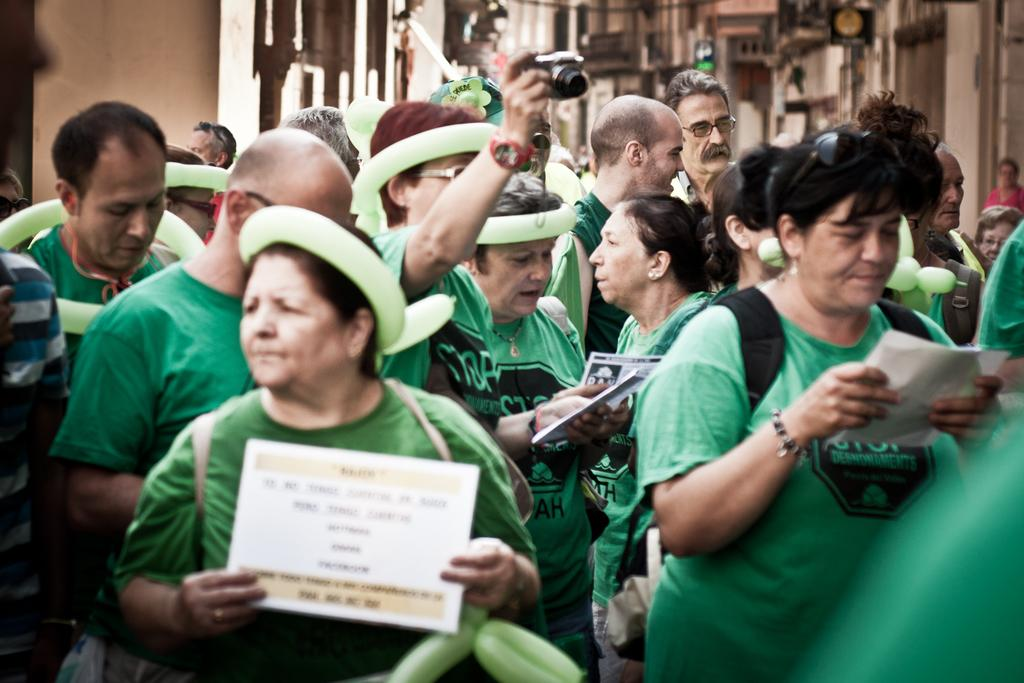How many people are in the image? There is a group of people in the image, but the exact number is not specified. What are the people holding in their hands? The people are holding papers in their hands. Can you describe the person who is holding a camera? One person is holding a camera in the image. What can be seen in the background of the image? There are buildings and a board visible in the background. What type of health benefits can be gained from the magic slope in the image? There is no mention of a magic slope or any health benefits in the image. 